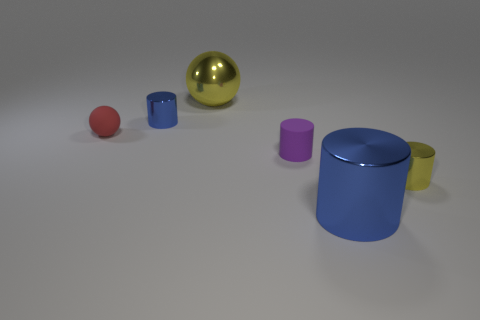Add 2 big yellow metallic spheres. How many objects exist? 8 Subtract all spheres. How many objects are left? 4 Add 6 cyan cylinders. How many cyan cylinders exist? 6 Subtract 0 purple cubes. How many objects are left? 6 Subtract all green metal cylinders. Subtract all yellow shiny things. How many objects are left? 4 Add 5 tiny blue things. How many tiny blue things are left? 6 